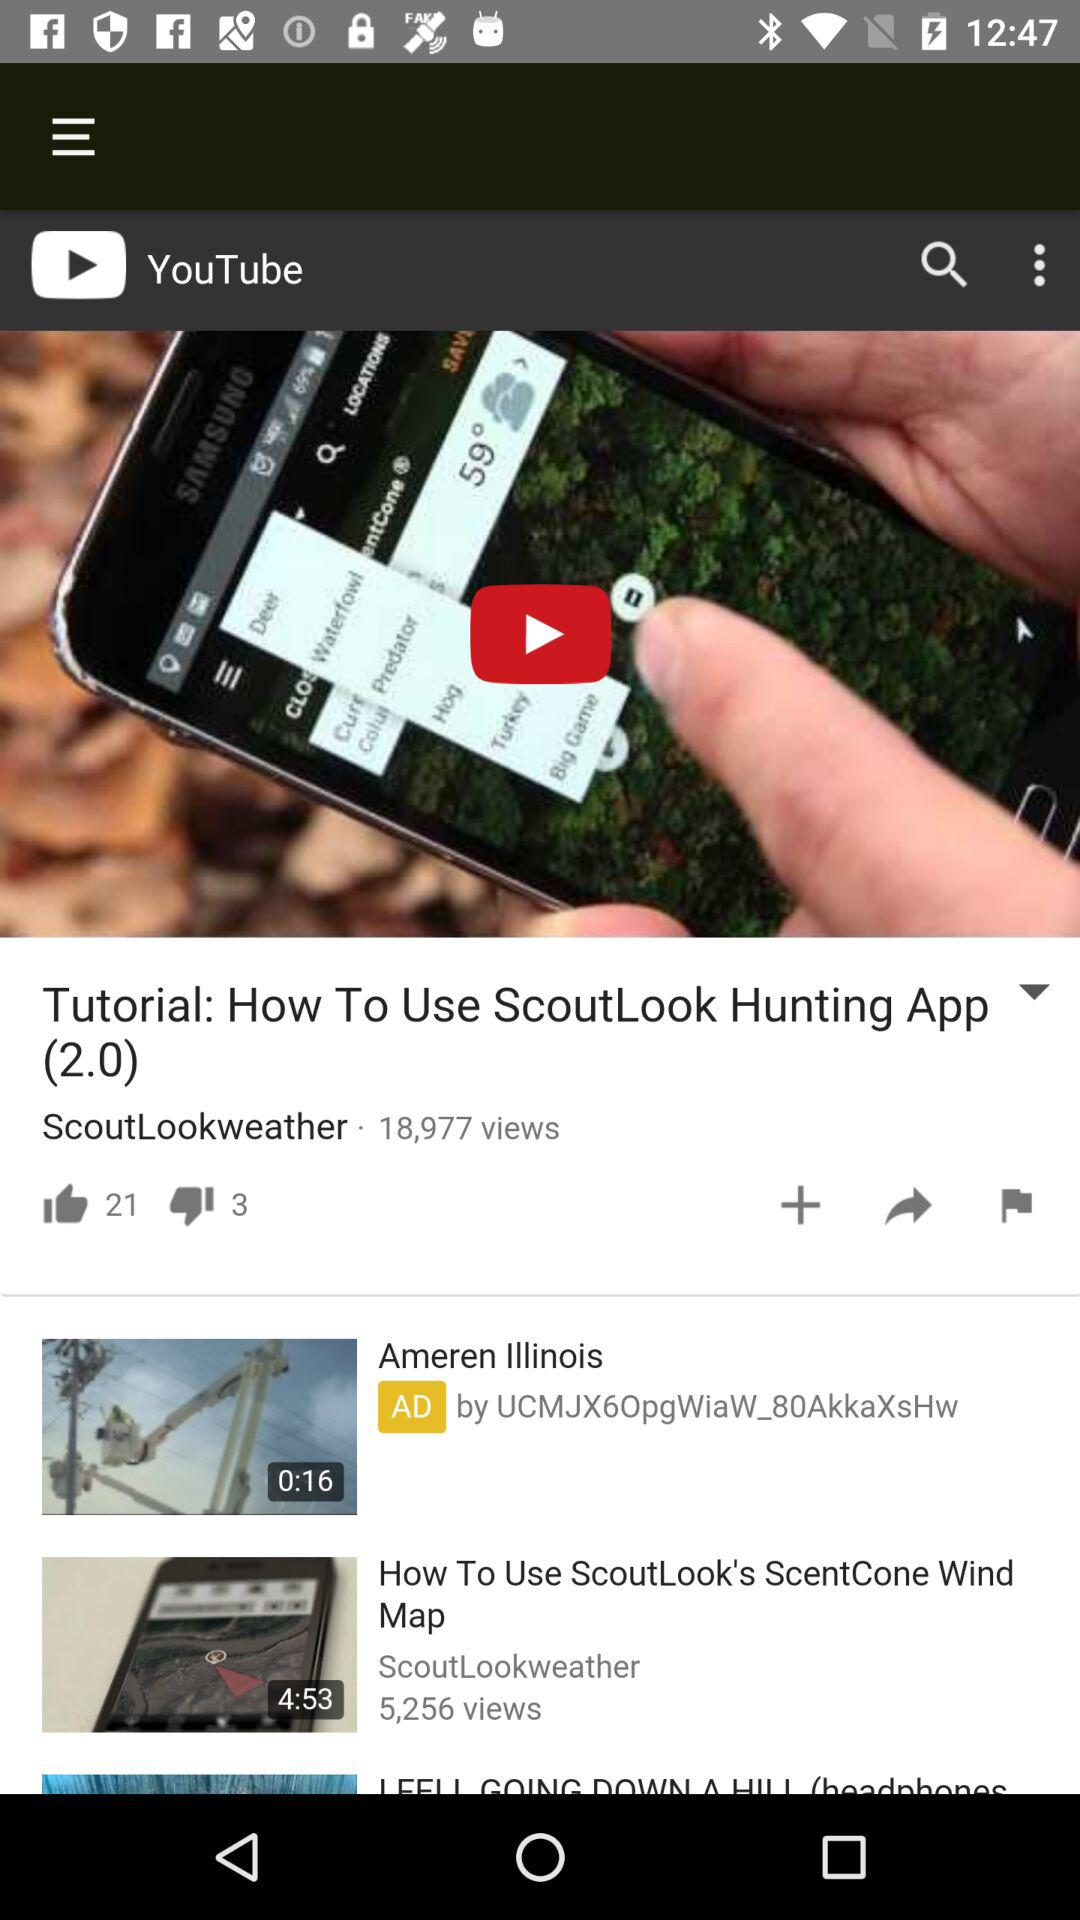What is the name of the application? The name of the application is "YouTube". 